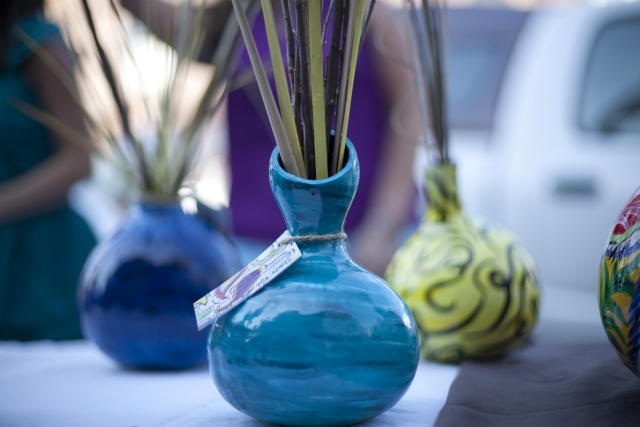Describe the objects in this image and their specific colors. I can see potted plant in black, teal, gray, blue, and lightblue tones, potted plant in black, gray, lightgray, navy, and darkgray tones, vase in black, teal, blue, lightblue, and darkblue tones, people in black, navy, darkblue, gray, and blue tones, and potted plant in black, gray, olive, darkgreen, and darkgray tones in this image. 